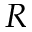<formula> <loc_0><loc_0><loc_500><loc_500>R</formula> 